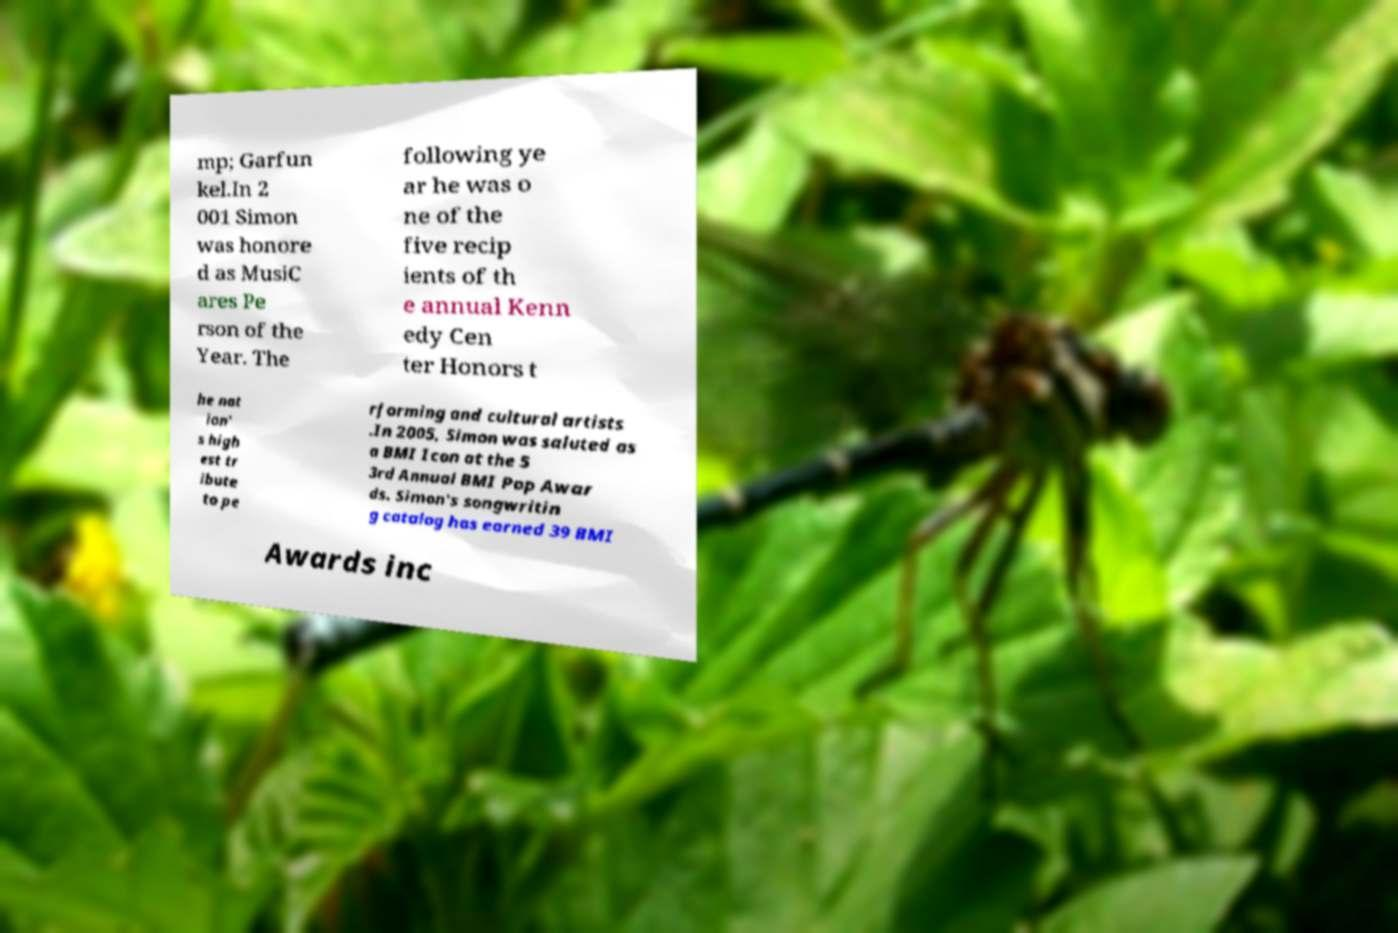There's text embedded in this image that I need extracted. Can you transcribe it verbatim? mp; Garfun kel.In 2 001 Simon was honore d as MusiC ares Pe rson of the Year. The following ye ar he was o ne of the five recip ients of th e annual Kenn edy Cen ter Honors t he nat ion' s high est tr ibute to pe rforming and cultural artists .In 2005, Simon was saluted as a BMI Icon at the 5 3rd Annual BMI Pop Awar ds. Simon's songwritin g catalog has earned 39 BMI Awards inc 